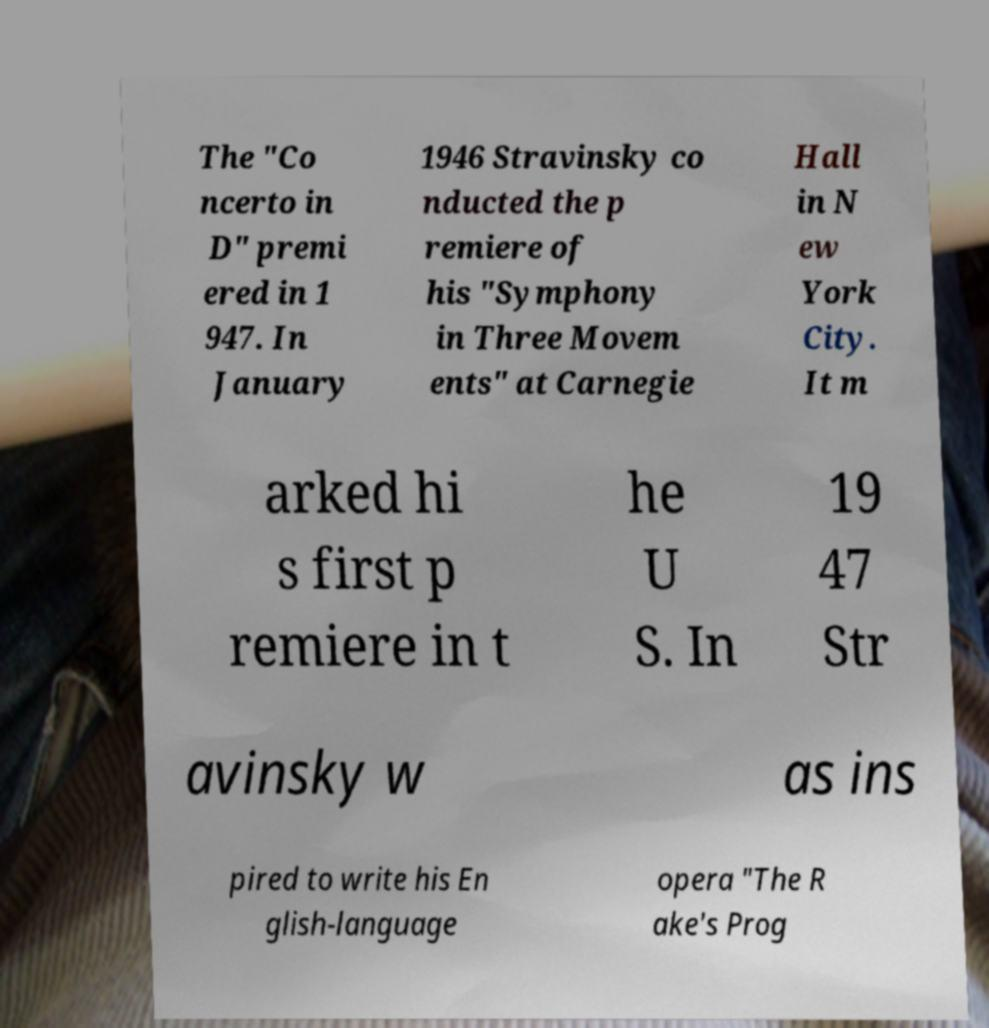For documentation purposes, I need the text within this image transcribed. Could you provide that? The "Co ncerto in D" premi ered in 1 947. In January 1946 Stravinsky co nducted the p remiere of his "Symphony in Three Movem ents" at Carnegie Hall in N ew York City. It m arked hi s first p remiere in t he U S. In 19 47 Str avinsky w as ins pired to write his En glish-language opera "The R ake's Prog 